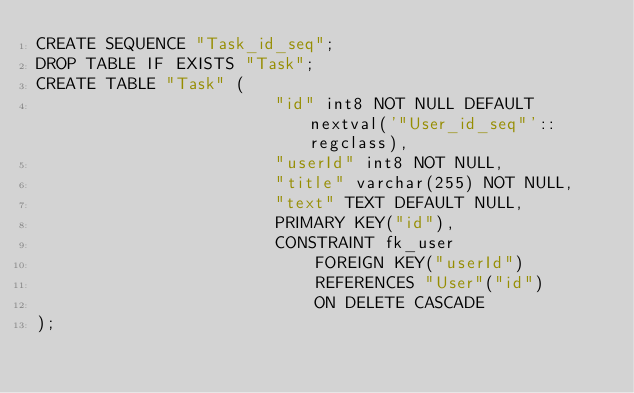Convert code to text. <code><loc_0><loc_0><loc_500><loc_500><_SQL_>CREATE SEQUENCE "Task_id_seq";
DROP TABLE IF EXISTS "Task";
CREATE TABLE "Task" (
                        "id" int8 NOT NULL DEFAULT nextval('"User_id_seq"'::regclass),
                        "userId" int8 NOT NULL,
                        "title" varchar(255) NOT NULL,
                        "text" TEXT DEFAULT NULL,
                        PRIMARY KEY("id"),
                        CONSTRAINT fk_user
                            FOREIGN KEY("userId")
                            REFERENCES "User"("id")
                            ON DELETE CASCADE
);
</code> 